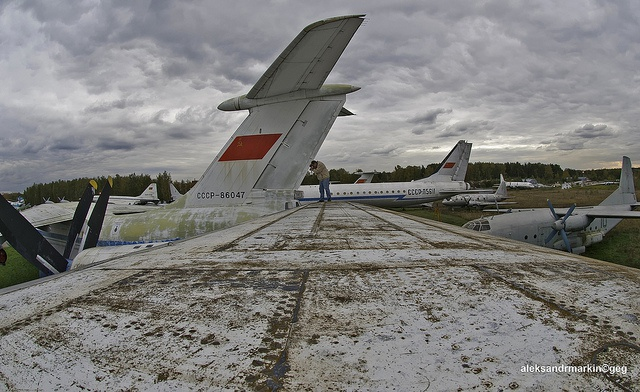Describe the objects in this image and their specific colors. I can see airplane in gray, darkgray, black, and maroon tones, airplane in gray, black, and darkgray tones, airplane in gray, black, and purple tones, airplane in gray, black, and darkgray tones, and airplane in gray, darkgray, black, and lightgray tones in this image. 